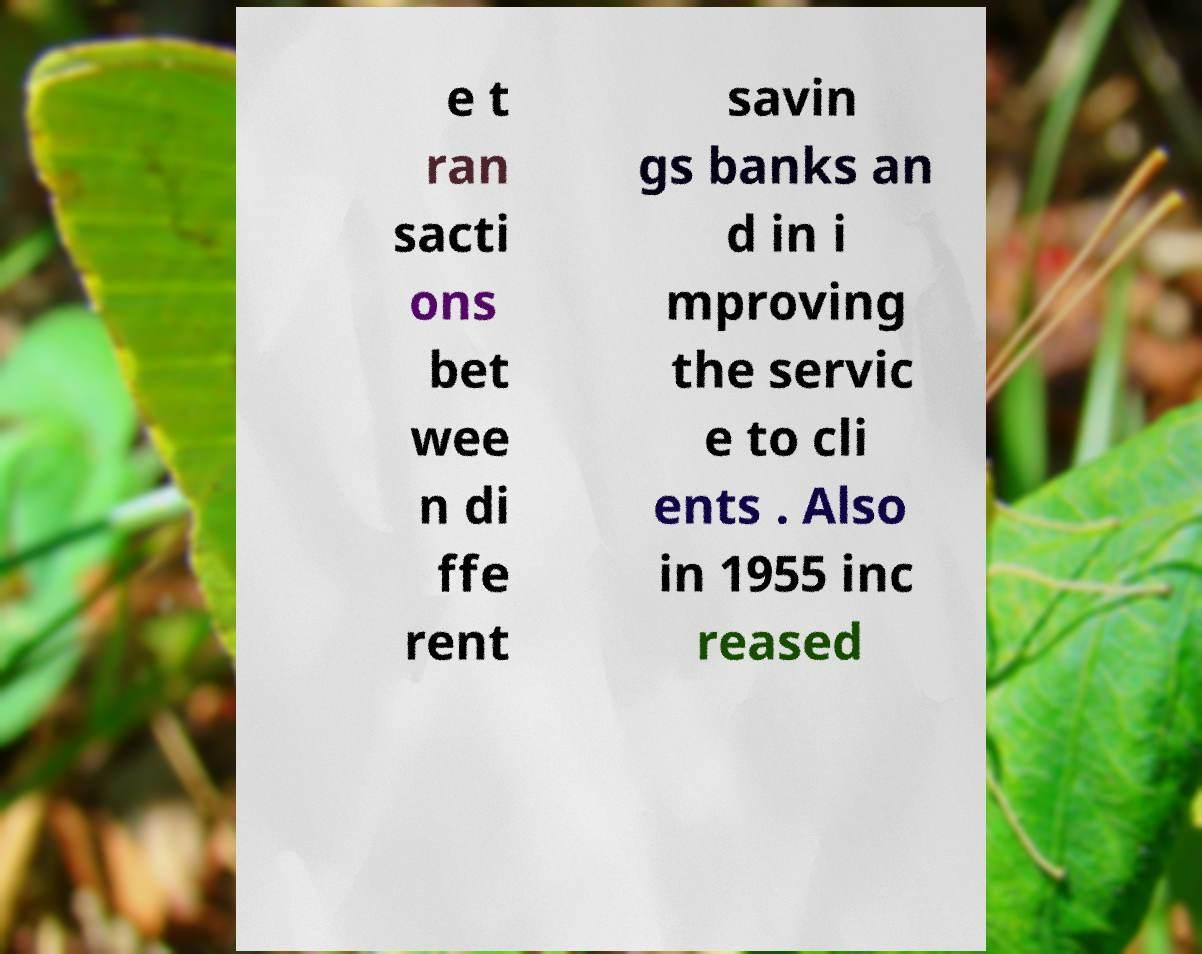I need the written content from this picture converted into text. Can you do that? e t ran sacti ons bet wee n di ffe rent savin gs banks an d in i mproving the servic e to cli ents . Also in 1955 inc reased 